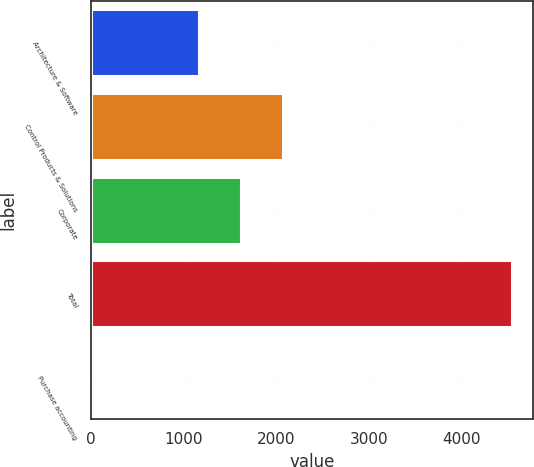Convert chart to OTSL. <chart><loc_0><loc_0><loc_500><loc_500><bar_chart><fcel>Architecture & Software<fcel>Control Products & Solutions<fcel>Corporate<fcel>Total<fcel>Purchase accounting<nl><fcel>1163.6<fcel>2069.48<fcel>1616.54<fcel>4545.8<fcel>16.4<nl></chart> 